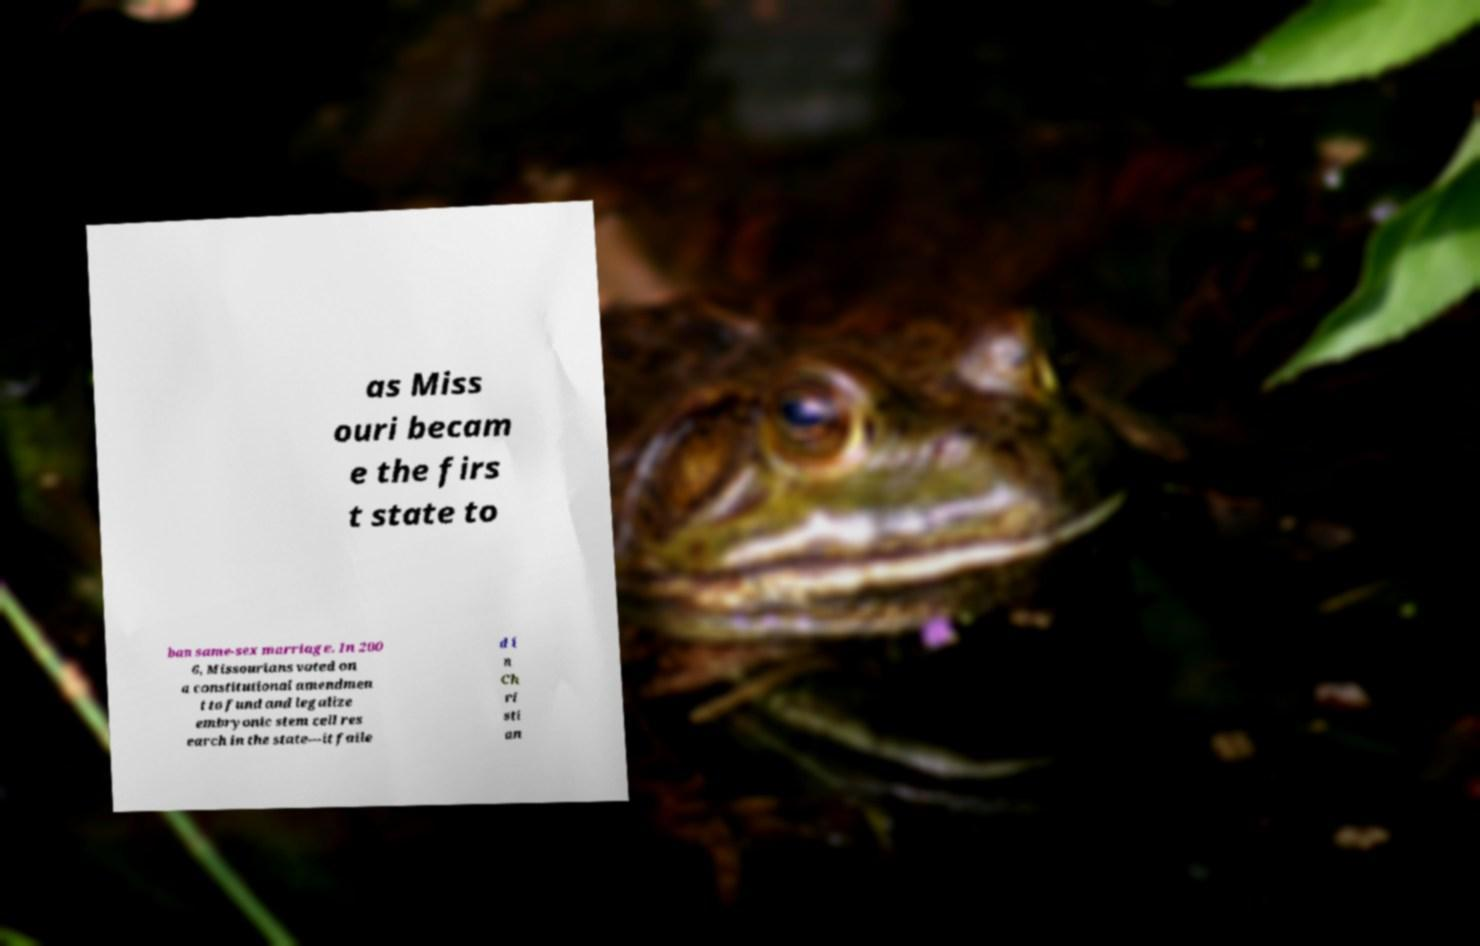Can you accurately transcribe the text from the provided image for me? as Miss ouri becam e the firs t state to ban same-sex marriage. In 200 6, Missourians voted on a constitutional amendmen t to fund and legalize embryonic stem cell res earch in the state—it faile d i n Ch ri sti an 